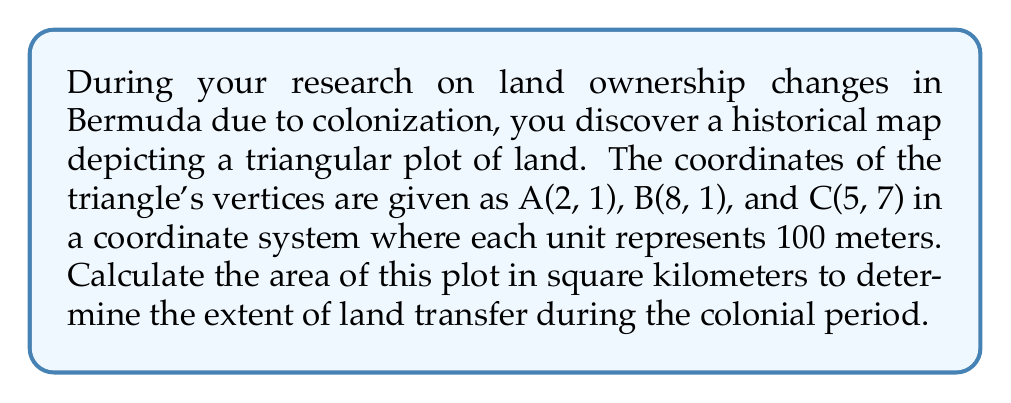Show me your answer to this math problem. To solve this problem, we'll follow these steps:

1. Visualize the triangle in the coordinate plane:

[asy]
unitsize(1cm);
defaultpen(fontsize(10pt));

pair A = (2,1);
pair B = (8,1);
pair C = (5,7);

draw(A--B--C--cycle);

dot("A(2,1)", A, SW);
dot("B(8,1)", B, SE);
dot("C(5,7)", C, N);

xaxis(0,9,arrow=Arrow);
yaxis(0,8,arrow=Arrow);
[/asy]

2. Use the formula for the area of a triangle given three vertices:

$$\text{Area} = \frac{1}{2}|x_1(y_2 - y_3) + x_2(y_3 - y_1) + x_3(y_1 - y_2)|$$

Where $(x_1, y_1)$, $(x_2, y_2)$, and $(x_3, y_3)$ are the coordinates of the three vertices.

3. Substitute the values:
   $x_1 = 2, y_1 = 1$
   $x_2 = 8, y_2 = 1$
   $x_3 = 5, y_3 = 7$

$$\text{Area} = \frac{1}{2}|2(1 - 7) + 8(7 - 1) + 5(1 - 1)|$$

4. Simplify:

$$\begin{align*}
\text{Area} &= \frac{1}{2}|2(-6) + 8(6) + 5(0)| \\
&= \frac{1}{2}|-12 + 48 + 0| \\
&= \frac{1}{2}|36| \\
&= \frac{1}{2} \cdot 36 \\
&= 18 \text{ square units}
\end{align*}$$

5. Convert to square kilometers:
   Each unit represents 100 meters, so 1 square unit = $(100 \text{ m})^2 = 10,000 \text{ m}^2$
   
   $18 \text{ square units} = 18 \cdot 10,000 \text{ m}^2 = 180,000 \text{ m}^2$
   
   $180,000 \text{ m}^2 = 0.18 \text{ km}^2$

Therefore, the area of the triangular plot is 0.18 square kilometers.
Answer: 0.18 km² 